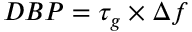Convert formula to latex. <formula><loc_0><loc_0><loc_500><loc_500>D B P = \tau _ { g } \times \Delta f</formula> 